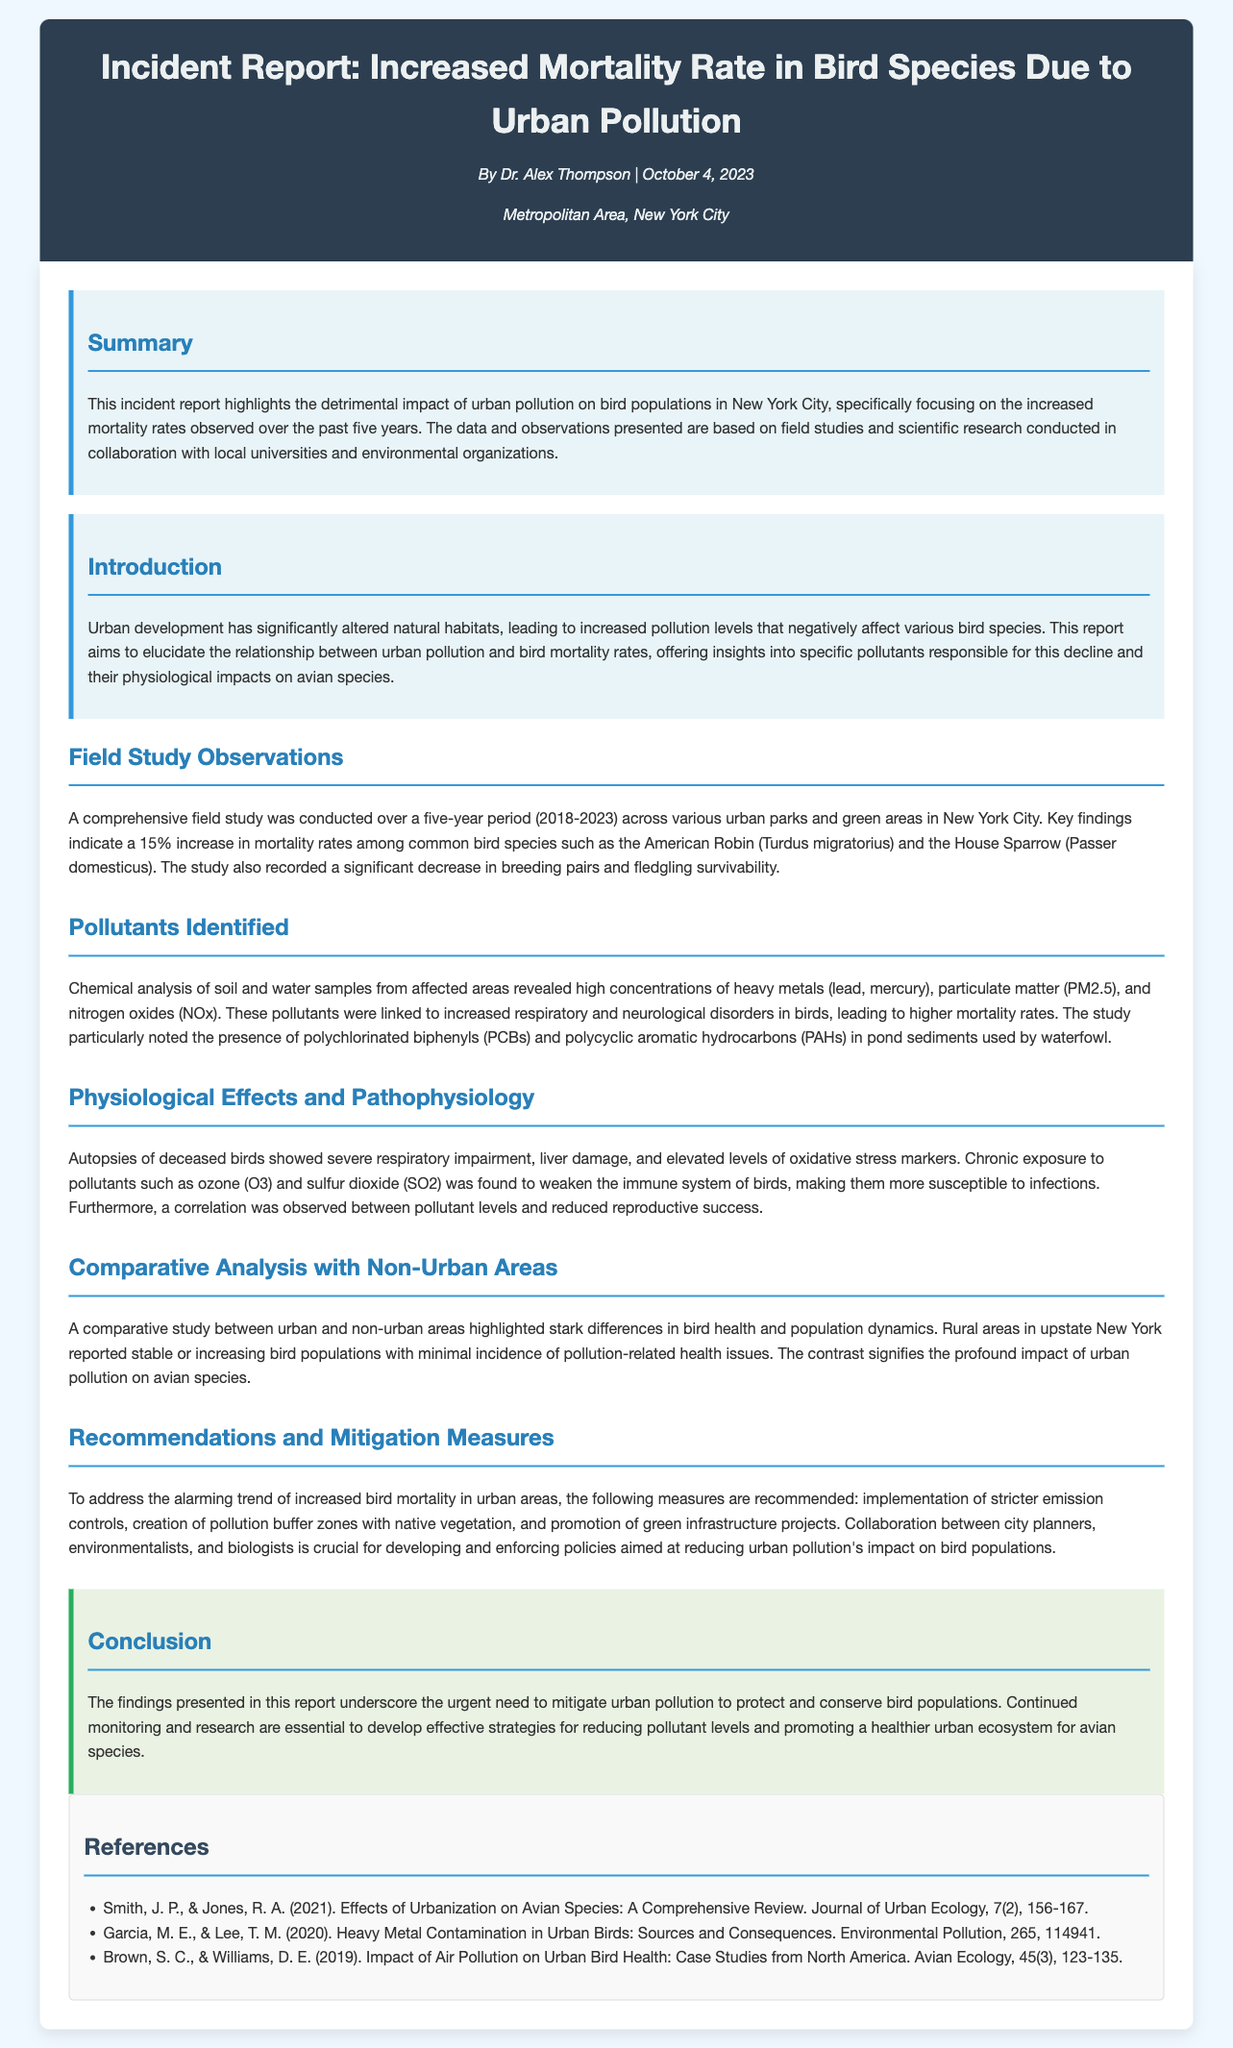what is the title of the report? The title of the report is stated at the beginning of the document, highlighting the main topic addressed.
Answer: Incident Report: Increased Mortality Rate in Bird Species Due to Urban Pollution who is the author of the report? The author is mentioned in the header section of the document along with the date of publication.
Answer: Dr. Alex Thompson what is the date of the report? The date is provided along with the author's name in the header section, indicating when the report was published.
Answer: October 4, 2023 what was the percentage increase in bird mortality rates? The specific percentage increase in mortality rates is highlighted in the field study observations section.
Answer: 15% which bird species showed increased mortality rates? The document specifies bird species that have been affected by urban pollution, emphasizing their names.
Answer: American Robin, House Sparrow what pollutants were identified in the study? The pollutants identified are detailed in the section discussing chemical analysis of samples taken from the study area.
Answer: heavy metals, particulate matter, nitrogen oxides what physiological effects were observed in the deceased birds? The autopsy findings detail the observed physiological issues in birds that died due to pollution exposure.
Answer: respiratory impairment, liver damage how do urban and non-urban bird populations compare? The document contains a comparative analysis section indicating the differences in health and population dynamics between urban and non-urban areas.
Answer: stark differences what are the recommendations made to address bird mortality? The conclusion section summarizes the recommended actions to mitigate the impact of urban pollution on birds.
Answer: stricter emission controls, pollution buffer zones, green infrastructure projects 